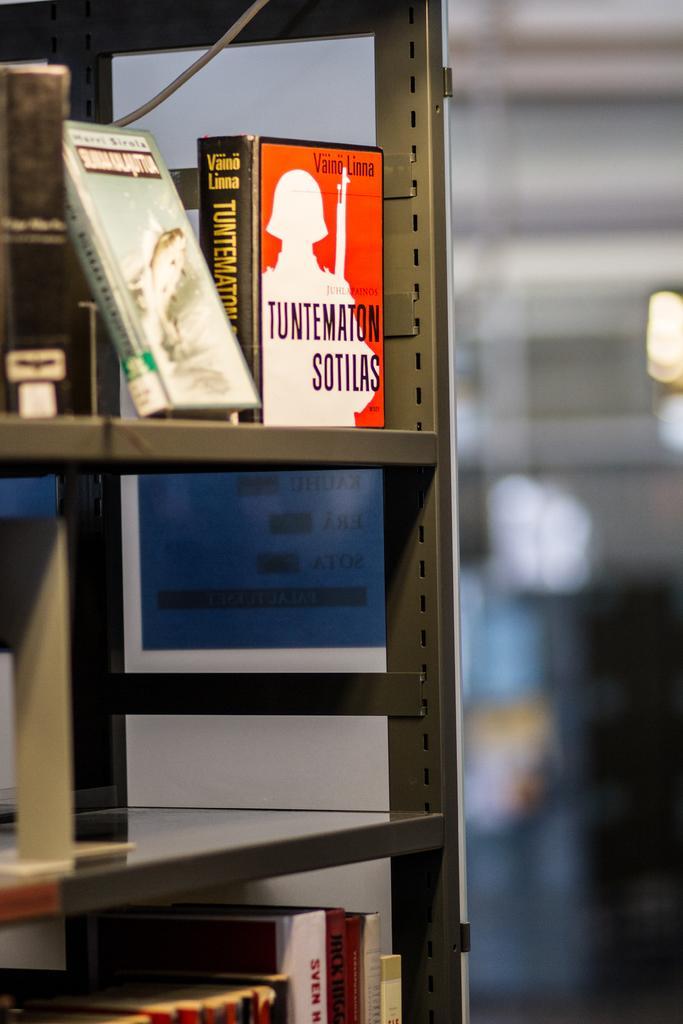Describe this image in one or two sentences. This image is taken indoors. In this image the background is a little blurred. On the left side of the image there is a rack with shelves. There are a few books on the shelves. 